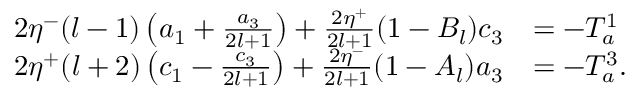<formula> <loc_0><loc_0><loc_500><loc_500>\begin{array} { r l } { 2 \eta ^ { - } ( l - 1 ) \left ( a _ { 1 } + \frac { a _ { 3 } } { 2 l + 1 } \right ) + \frac { 2 \eta ^ { + } } { 2 l + 1 } ( 1 - B _ { l } ) c _ { 3 } } & { = - T _ { a } ^ { 1 } } \\ { 2 \eta ^ { + } ( l + 2 ) \left ( c _ { 1 } - \frac { c _ { 3 } } { 2 l + 1 } \right ) + \frac { 2 \eta ^ { - } } { 2 l + 1 } ( 1 - A _ { l } ) a _ { 3 } } & { = - T _ { a } ^ { 3 } . } \end{array}</formula> 